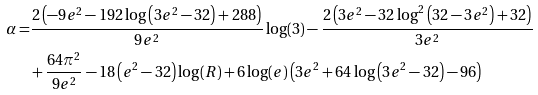<formula> <loc_0><loc_0><loc_500><loc_500>\alpha = & \frac { 2 \left ( - 9 e ^ { 2 } - 1 9 2 \log \left ( 3 e ^ { 2 } - 3 2 \right ) + 2 8 8 \right ) } { 9 e ^ { 2 } } \log ( 3 ) - \frac { 2 \left ( 3 e ^ { 2 } - 3 2 \log ^ { 2 } \left ( 3 2 - 3 e ^ { 2 } \right ) + 3 2 \right ) } { 3 e ^ { 2 } } \\ & + \frac { 6 4 \pi ^ { 2 } } { 9 e ^ { 2 } } - 1 8 \left ( e ^ { 2 } - 3 2 \right ) \log ( R ) + 6 \log ( e ) \left ( 3 e ^ { 2 } + 6 4 \log \left ( 3 e ^ { 2 } - 3 2 \right ) - 9 6 \right )</formula> 